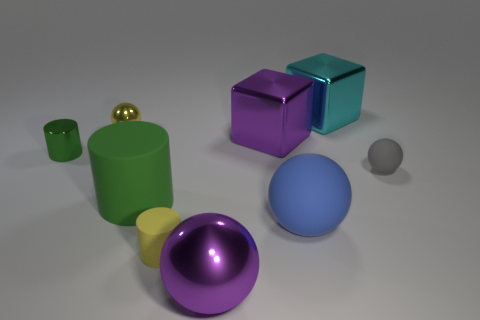What is the shape of the big thing that is in front of the small thing in front of the gray ball that is to the right of the blue object?
Provide a short and direct response. Sphere. How many small green metal things are to the left of the green object left of the small yellow shiny sphere?
Provide a succinct answer. 0. Does the small yellow sphere have the same material as the purple ball?
Provide a succinct answer. Yes. There is a tiny matte object that is to the right of the big sphere behind the small rubber cylinder; what number of cyan things are in front of it?
Offer a very short reply. 0. There is a large metal object behind the purple metal cube; what is its color?
Keep it short and to the point. Cyan. What shape is the yellow object that is on the left side of the tiny cylinder that is right of the tiny metallic cylinder?
Keep it short and to the point. Sphere. Is the color of the small rubber sphere the same as the shiny cylinder?
Your answer should be very brief. No. What number of cubes are either green metal things or tiny shiny objects?
Ensure brevity in your answer.  0. The sphere that is in front of the small gray matte thing and behind the purple ball is made of what material?
Offer a very short reply. Rubber. There is a tiny green object; what number of big rubber balls are left of it?
Keep it short and to the point. 0. 